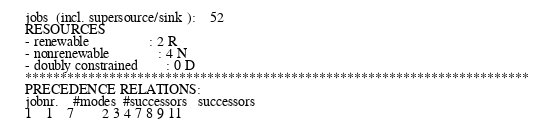Convert code to text. <code><loc_0><loc_0><loc_500><loc_500><_ObjectiveC_>jobs  (incl. supersource/sink ):	52
RESOURCES
- renewable                 : 2 R
- nonrenewable              : 4 N
- doubly constrained        : 0 D
************************************************************************
PRECEDENCE RELATIONS:
jobnr.    #modes  #successors   successors
1	1	7		2 3 4 7 8 9 11 </code> 